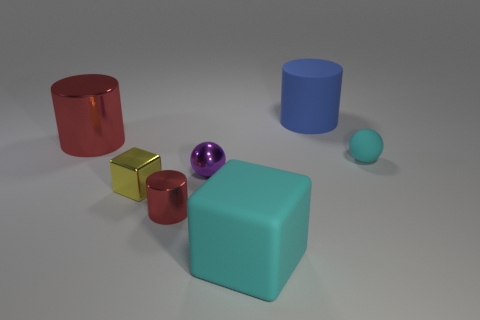What theme could this assortment of shapes represent? This image could symbolize diversity and unity, illustrating how various shapes and colors can coexist harmoniously within the same space. Can you expand on that idea? Certainly. The collection of objects, despite their differences in size, color, and shape, are arranged neatly and coherently, much like a well-functioning society that values a range of individual characteristics and talents. 